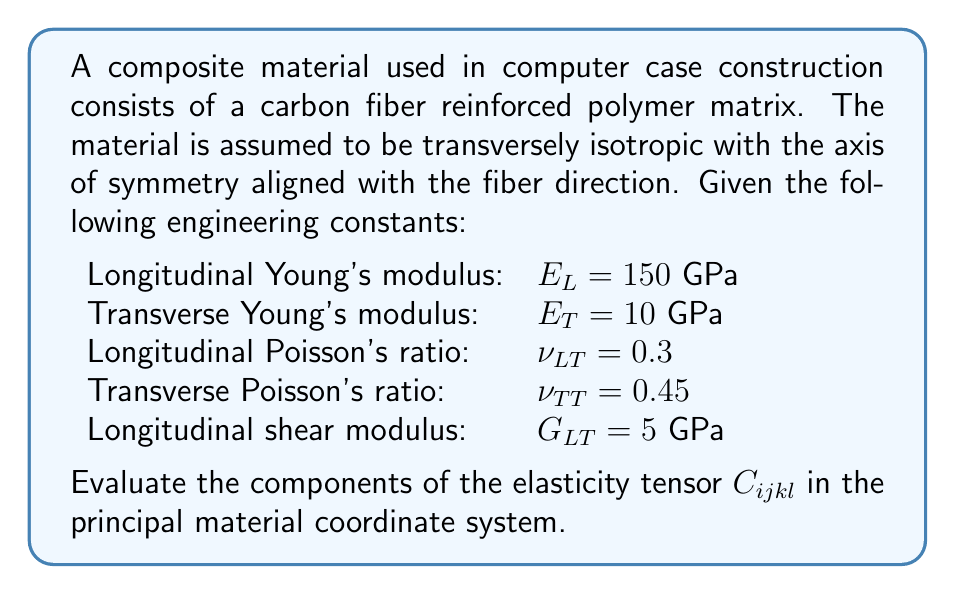Provide a solution to this math problem. To evaluate the elasticity tensor for a transversely isotropic material, we follow these steps:

1) For a transversely isotropic material, the elasticity tensor has 5 independent components. In contracted notation, these are $C_{11}$, $C_{12}$, $C_{13}$, $C_{33}$, and $C_{44}$.

2) We can express these components in terms of the given engineering constants:

   $$C_{11} = \frac{E_T(1-\nu_{LT}^2E_T/E_L)}{(1+\nu_{TT})(1-\nu_{TT}-2\nu_{LT}^2E_T/E_L)}$$

   $$C_{12} = \frac{E_T(\nu_{TT}+\nu_{LT}^2E_T/E_L)}{(1+\nu_{TT})(1-\nu_{TT}-2\nu_{LT}^2E_T/E_L)}$$

   $$C_{13} = \frac{E_T\nu_{LT}}{1-\nu_{LT}^2E_T/E_L}$$

   $$C_{33} = E_L(1-\nu_{TT}^2)$$

   $$C_{44} = G_{LT}$$

3) Substituting the given values:

   $$C_{11} = \frac{10(1-0.3^2\cdot10/150)}{(1+0.45)(1-0.45-2\cdot0.3^2\cdot10/150)} = 14.1 \text{ GPa}$$

   $$C_{12} = \frac{10(0.45+0.3^2\cdot10/150)}{(1+0.45)(1-0.45-2\cdot0.3^2\cdot10/150)} = 6.3 \text{ GPa}$$

   $$C_{13} = \frac{10\cdot0.3}{1-0.3^2\cdot10/150} = 3.0 \text{ GPa}$$

   $$C_{33} = 150(1-0.45^2) = 129.9 \text{ GPa}$$

   $$C_{44} = 5 \text{ GPa}$$

4) The full elasticity tensor in contracted notation is:

   $$C_{ij} = \begin{bmatrix}
   14.1 & 6.3 & 3.0 & 0 & 0 & 0 \\
   6.3 & 14.1 & 3.0 & 0 & 0 & 0 \\
   3.0 & 3.0 & 129.9 & 0 & 0 & 0 \\
   0 & 0 & 0 & 5.0 & 0 & 0 \\
   0 & 0 & 0 & 0 & 5.0 & 0 \\
   0 & 0 & 0 & 0 & 0 & 3.9
   \end{bmatrix}$$

   where $C_{66} = (C_{11} - C_{12})/2 = 3.9$ GPa.

5) To convert back to the full tensor notation $C_{ijkl}$, we use the relationship between contracted and full notation, keeping in mind the symmetry of the tensor.
Answer: $C_{ijkl} = \begin{bmatrix}
14.1 & 6.3 & 3.0 & 0 & 0 & 0 \\
6.3 & 14.1 & 3.0 & 0 & 0 & 0 \\
3.0 & 3.0 & 129.9 & 0 & 0 & 0 \\
0 & 0 & 0 & 5.0 & 0 & 0 \\
0 & 0 & 0 & 0 & 5.0 & 0 \\
0 & 0 & 0 & 0 & 0 & 3.9
\end{bmatrix}$ GPa (in contracted notation) 